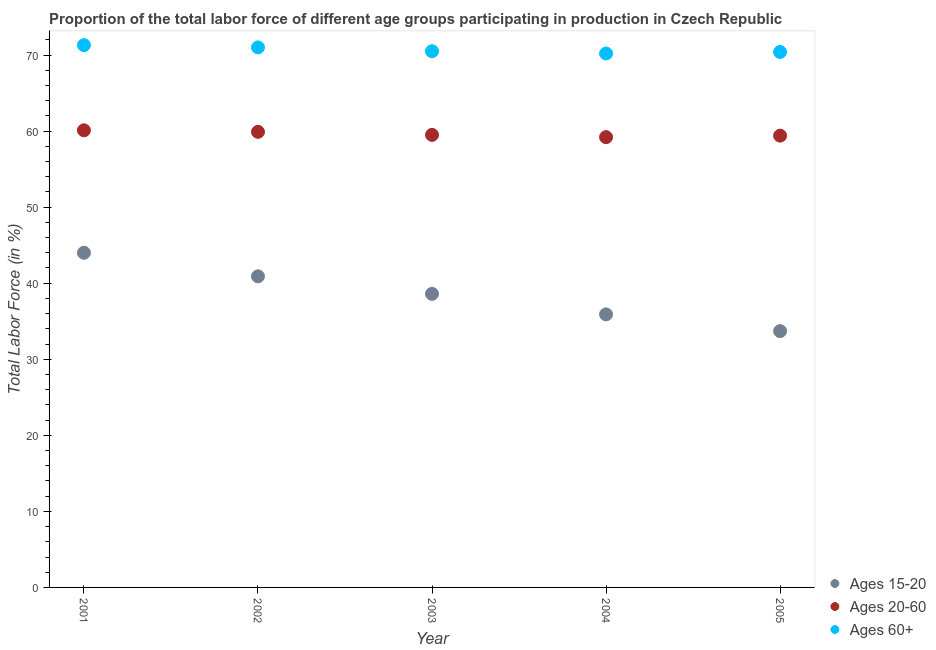How many different coloured dotlines are there?
Your answer should be compact. 3. Is the number of dotlines equal to the number of legend labels?
Offer a very short reply. Yes. What is the percentage of labor force above age 60 in 2003?
Offer a very short reply. 70.5. Across all years, what is the maximum percentage of labor force within the age group 20-60?
Your answer should be very brief. 60.1. Across all years, what is the minimum percentage of labor force above age 60?
Make the answer very short. 70.2. In which year was the percentage of labor force within the age group 20-60 maximum?
Give a very brief answer. 2001. What is the total percentage of labor force within the age group 20-60 in the graph?
Provide a succinct answer. 298.1. What is the difference between the percentage of labor force above age 60 in 2001 and that in 2003?
Give a very brief answer. 0.8. What is the difference between the percentage of labor force above age 60 in 2005 and the percentage of labor force within the age group 15-20 in 2004?
Your response must be concise. 34.5. What is the average percentage of labor force above age 60 per year?
Keep it short and to the point. 70.68. In the year 2001, what is the difference between the percentage of labor force above age 60 and percentage of labor force within the age group 20-60?
Provide a short and direct response. 11.2. In how many years, is the percentage of labor force above age 60 greater than 46 %?
Ensure brevity in your answer.  5. What is the ratio of the percentage of labor force within the age group 20-60 in 2002 to that in 2003?
Provide a short and direct response. 1.01. What is the difference between the highest and the second highest percentage of labor force above age 60?
Ensure brevity in your answer.  0.3. What is the difference between the highest and the lowest percentage of labor force above age 60?
Make the answer very short. 1.1. Is it the case that in every year, the sum of the percentage of labor force within the age group 15-20 and percentage of labor force within the age group 20-60 is greater than the percentage of labor force above age 60?
Offer a very short reply. Yes. How many dotlines are there?
Give a very brief answer. 3. How many years are there in the graph?
Make the answer very short. 5. Are the values on the major ticks of Y-axis written in scientific E-notation?
Provide a short and direct response. No. Does the graph contain grids?
Offer a terse response. No. Where does the legend appear in the graph?
Ensure brevity in your answer.  Bottom right. How many legend labels are there?
Offer a very short reply. 3. How are the legend labels stacked?
Your answer should be very brief. Vertical. What is the title of the graph?
Offer a very short reply. Proportion of the total labor force of different age groups participating in production in Czech Republic. What is the label or title of the X-axis?
Offer a very short reply. Year. What is the label or title of the Y-axis?
Your answer should be compact. Total Labor Force (in %). What is the Total Labor Force (in %) in Ages 15-20 in 2001?
Your answer should be compact. 44. What is the Total Labor Force (in %) in Ages 20-60 in 2001?
Your answer should be very brief. 60.1. What is the Total Labor Force (in %) of Ages 60+ in 2001?
Provide a short and direct response. 71.3. What is the Total Labor Force (in %) of Ages 15-20 in 2002?
Your response must be concise. 40.9. What is the Total Labor Force (in %) of Ages 20-60 in 2002?
Give a very brief answer. 59.9. What is the Total Labor Force (in %) in Ages 15-20 in 2003?
Ensure brevity in your answer.  38.6. What is the Total Labor Force (in %) in Ages 20-60 in 2003?
Make the answer very short. 59.5. What is the Total Labor Force (in %) in Ages 60+ in 2003?
Your response must be concise. 70.5. What is the Total Labor Force (in %) of Ages 15-20 in 2004?
Give a very brief answer. 35.9. What is the Total Labor Force (in %) in Ages 20-60 in 2004?
Offer a terse response. 59.2. What is the Total Labor Force (in %) of Ages 60+ in 2004?
Your answer should be compact. 70.2. What is the Total Labor Force (in %) of Ages 15-20 in 2005?
Give a very brief answer. 33.7. What is the Total Labor Force (in %) of Ages 20-60 in 2005?
Give a very brief answer. 59.4. What is the Total Labor Force (in %) of Ages 60+ in 2005?
Offer a very short reply. 70.4. Across all years, what is the maximum Total Labor Force (in %) in Ages 20-60?
Ensure brevity in your answer.  60.1. Across all years, what is the maximum Total Labor Force (in %) of Ages 60+?
Keep it short and to the point. 71.3. Across all years, what is the minimum Total Labor Force (in %) of Ages 15-20?
Provide a succinct answer. 33.7. Across all years, what is the minimum Total Labor Force (in %) of Ages 20-60?
Keep it short and to the point. 59.2. Across all years, what is the minimum Total Labor Force (in %) of Ages 60+?
Your answer should be very brief. 70.2. What is the total Total Labor Force (in %) of Ages 15-20 in the graph?
Offer a terse response. 193.1. What is the total Total Labor Force (in %) of Ages 20-60 in the graph?
Your answer should be compact. 298.1. What is the total Total Labor Force (in %) of Ages 60+ in the graph?
Give a very brief answer. 353.4. What is the difference between the Total Labor Force (in %) in Ages 20-60 in 2001 and that in 2002?
Ensure brevity in your answer.  0.2. What is the difference between the Total Labor Force (in %) in Ages 60+ in 2001 and that in 2002?
Provide a short and direct response. 0.3. What is the difference between the Total Labor Force (in %) in Ages 20-60 in 2001 and that in 2004?
Offer a terse response. 0.9. What is the difference between the Total Labor Force (in %) in Ages 15-20 in 2001 and that in 2005?
Give a very brief answer. 10.3. What is the difference between the Total Labor Force (in %) of Ages 60+ in 2001 and that in 2005?
Ensure brevity in your answer.  0.9. What is the difference between the Total Labor Force (in %) of Ages 20-60 in 2002 and that in 2004?
Provide a short and direct response. 0.7. What is the difference between the Total Labor Force (in %) in Ages 15-20 in 2002 and that in 2005?
Provide a succinct answer. 7.2. What is the difference between the Total Labor Force (in %) of Ages 60+ in 2002 and that in 2005?
Make the answer very short. 0.6. What is the difference between the Total Labor Force (in %) in Ages 60+ in 2003 and that in 2004?
Your response must be concise. 0.3. What is the difference between the Total Labor Force (in %) of Ages 20-60 in 2003 and that in 2005?
Make the answer very short. 0.1. What is the difference between the Total Labor Force (in %) of Ages 60+ in 2003 and that in 2005?
Ensure brevity in your answer.  0.1. What is the difference between the Total Labor Force (in %) in Ages 15-20 in 2004 and that in 2005?
Your response must be concise. 2.2. What is the difference between the Total Labor Force (in %) of Ages 20-60 in 2004 and that in 2005?
Ensure brevity in your answer.  -0.2. What is the difference between the Total Labor Force (in %) in Ages 60+ in 2004 and that in 2005?
Make the answer very short. -0.2. What is the difference between the Total Labor Force (in %) of Ages 15-20 in 2001 and the Total Labor Force (in %) of Ages 20-60 in 2002?
Offer a terse response. -15.9. What is the difference between the Total Labor Force (in %) in Ages 15-20 in 2001 and the Total Labor Force (in %) in Ages 20-60 in 2003?
Keep it short and to the point. -15.5. What is the difference between the Total Labor Force (in %) of Ages 15-20 in 2001 and the Total Labor Force (in %) of Ages 60+ in 2003?
Make the answer very short. -26.5. What is the difference between the Total Labor Force (in %) in Ages 20-60 in 2001 and the Total Labor Force (in %) in Ages 60+ in 2003?
Offer a terse response. -10.4. What is the difference between the Total Labor Force (in %) of Ages 15-20 in 2001 and the Total Labor Force (in %) of Ages 20-60 in 2004?
Keep it short and to the point. -15.2. What is the difference between the Total Labor Force (in %) of Ages 15-20 in 2001 and the Total Labor Force (in %) of Ages 60+ in 2004?
Provide a succinct answer. -26.2. What is the difference between the Total Labor Force (in %) in Ages 15-20 in 2001 and the Total Labor Force (in %) in Ages 20-60 in 2005?
Give a very brief answer. -15.4. What is the difference between the Total Labor Force (in %) of Ages 15-20 in 2001 and the Total Labor Force (in %) of Ages 60+ in 2005?
Your answer should be very brief. -26.4. What is the difference between the Total Labor Force (in %) of Ages 15-20 in 2002 and the Total Labor Force (in %) of Ages 20-60 in 2003?
Offer a terse response. -18.6. What is the difference between the Total Labor Force (in %) of Ages 15-20 in 2002 and the Total Labor Force (in %) of Ages 60+ in 2003?
Your answer should be compact. -29.6. What is the difference between the Total Labor Force (in %) in Ages 20-60 in 2002 and the Total Labor Force (in %) in Ages 60+ in 2003?
Ensure brevity in your answer.  -10.6. What is the difference between the Total Labor Force (in %) in Ages 15-20 in 2002 and the Total Labor Force (in %) in Ages 20-60 in 2004?
Give a very brief answer. -18.3. What is the difference between the Total Labor Force (in %) in Ages 15-20 in 2002 and the Total Labor Force (in %) in Ages 60+ in 2004?
Your answer should be compact. -29.3. What is the difference between the Total Labor Force (in %) in Ages 15-20 in 2002 and the Total Labor Force (in %) in Ages 20-60 in 2005?
Ensure brevity in your answer.  -18.5. What is the difference between the Total Labor Force (in %) in Ages 15-20 in 2002 and the Total Labor Force (in %) in Ages 60+ in 2005?
Keep it short and to the point. -29.5. What is the difference between the Total Labor Force (in %) of Ages 20-60 in 2002 and the Total Labor Force (in %) of Ages 60+ in 2005?
Your answer should be very brief. -10.5. What is the difference between the Total Labor Force (in %) of Ages 15-20 in 2003 and the Total Labor Force (in %) of Ages 20-60 in 2004?
Provide a succinct answer. -20.6. What is the difference between the Total Labor Force (in %) of Ages 15-20 in 2003 and the Total Labor Force (in %) of Ages 60+ in 2004?
Your answer should be compact. -31.6. What is the difference between the Total Labor Force (in %) in Ages 20-60 in 2003 and the Total Labor Force (in %) in Ages 60+ in 2004?
Your answer should be compact. -10.7. What is the difference between the Total Labor Force (in %) of Ages 15-20 in 2003 and the Total Labor Force (in %) of Ages 20-60 in 2005?
Offer a very short reply. -20.8. What is the difference between the Total Labor Force (in %) in Ages 15-20 in 2003 and the Total Labor Force (in %) in Ages 60+ in 2005?
Your response must be concise. -31.8. What is the difference between the Total Labor Force (in %) in Ages 15-20 in 2004 and the Total Labor Force (in %) in Ages 20-60 in 2005?
Offer a very short reply. -23.5. What is the difference between the Total Labor Force (in %) of Ages 15-20 in 2004 and the Total Labor Force (in %) of Ages 60+ in 2005?
Offer a very short reply. -34.5. What is the average Total Labor Force (in %) of Ages 15-20 per year?
Offer a very short reply. 38.62. What is the average Total Labor Force (in %) of Ages 20-60 per year?
Provide a short and direct response. 59.62. What is the average Total Labor Force (in %) of Ages 60+ per year?
Your answer should be compact. 70.68. In the year 2001, what is the difference between the Total Labor Force (in %) in Ages 15-20 and Total Labor Force (in %) in Ages 20-60?
Your response must be concise. -16.1. In the year 2001, what is the difference between the Total Labor Force (in %) in Ages 15-20 and Total Labor Force (in %) in Ages 60+?
Make the answer very short. -27.3. In the year 2002, what is the difference between the Total Labor Force (in %) of Ages 15-20 and Total Labor Force (in %) of Ages 60+?
Make the answer very short. -30.1. In the year 2002, what is the difference between the Total Labor Force (in %) of Ages 20-60 and Total Labor Force (in %) of Ages 60+?
Make the answer very short. -11.1. In the year 2003, what is the difference between the Total Labor Force (in %) in Ages 15-20 and Total Labor Force (in %) in Ages 20-60?
Provide a succinct answer. -20.9. In the year 2003, what is the difference between the Total Labor Force (in %) of Ages 15-20 and Total Labor Force (in %) of Ages 60+?
Ensure brevity in your answer.  -31.9. In the year 2003, what is the difference between the Total Labor Force (in %) of Ages 20-60 and Total Labor Force (in %) of Ages 60+?
Provide a short and direct response. -11. In the year 2004, what is the difference between the Total Labor Force (in %) in Ages 15-20 and Total Labor Force (in %) in Ages 20-60?
Offer a very short reply. -23.3. In the year 2004, what is the difference between the Total Labor Force (in %) in Ages 15-20 and Total Labor Force (in %) in Ages 60+?
Provide a succinct answer. -34.3. In the year 2004, what is the difference between the Total Labor Force (in %) in Ages 20-60 and Total Labor Force (in %) in Ages 60+?
Your response must be concise. -11. In the year 2005, what is the difference between the Total Labor Force (in %) of Ages 15-20 and Total Labor Force (in %) of Ages 20-60?
Keep it short and to the point. -25.7. In the year 2005, what is the difference between the Total Labor Force (in %) in Ages 15-20 and Total Labor Force (in %) in Ages 60+?
Keep it short and to the point. -36.7. What is the ratio of the Total Labor Force (in %) in Ages 15-20 in 2001 to that in 2002?
Provide a succinct answer. 1.08. What is the ratio of the Total Labor Force (in %) of Ages 20-60 in 2001 to that in 2002?
Your answer should be compact. 1. What is the ratio of the Total Labor Force (in %) in Ages 15-20 in 2001 to that in 2003?
Make the answer very short. 1.14. What is the ratio of the Total Labor Force (in %) in Ages 60+ in 2001 to that in 2003?
Provide a succinct answer. 1.01. What is the ratio of the Total Labor Force (in %) of Ages 15-20 in 2001 to that in 2004?
Your answer should be very brief. 1.23. What is the ratio of the Total Labor Force (in %) of Ages 20-60 in 2001 to that in 2004?
Ensure brevity in your answer.  1.02. What is the ratio of the Total Labor Force (in %) of Ages 60+ in 2001 to that in 2004?
Your answer should be very brief. 1.02. What is the ratio of the Total Labor Force (in %) in Ages 15-20 in 2001 to that in 2005?
Make the answer very short. 1.31. What is the ratio of the Total Labor Force (in %) in Ages 20-60 in 2001 to that in 2005?
Offer a very short reply. 1.01. What is the ratio of the Total Labor Force (in %) of Ages 60+ in 2001 to that in 2005?
Your answer should be compact. 1.01. What is the ratio of the Total Labor Force (in %) in Ages 15-20 in 2002 to that in 2003?
Your response must be concise. 1.06. What is the ratio of the Total Labor Force (in %) of Ages 20-60 in 2002 to that in 2003?
Your answer should be very brief. 1.01. What is the ratio of the Total Labor Force (in %) in Ages 60+ in 2002 to that in 2003?
Provide a short and direct response. 1.01. What is the ratio of the Total Labor Force (in %) of Ages 15-20 in 2002 to that in 2004?
Make the answer very short. 1.14. What is the ratio of the Total Labor Force (in %) of Ages 20-60 in 2002 to that in 2004?
Give a very brief answer. 1.01. What is the ratio of the Total Labor Force (in %) in Ages 60+ in 2002 to that in 2004?
Ensure brevity in your answer.  1.01. What is the ratio of the Total Labor Force (in %) of Ages 15-20 in 2002 to that in 2005?
Provide a short and direct response. 1.21. What is the ratio of the Total Labor Force (in %) in Ages 20-60 in 2002 to that in 2005?
Offer a terse response. 1.01. What is the ratio of the Total Labor Force (in %) of Ages 60+ in 2002 to that in 2005?
Your response must be concise. 1.01. What is the ratio of the Total Labor Force (in %) in Ages 15-20 in 2003 to that in 2004?
Your answer should be compact. 1.08. What is the ratio of the Total Labor Force (in %) of Ages 15-20 in 2003 to that in 2005?
Ensure brevity in your answer.  1.15. What is the ratio of the Total Labor Force (in %) of Ages 15-20 in 2004 to that in 2005?
Provide a short and direct response. 1.07. What is the ratio of the Total Labor Force (in %) of Ages 20-60 in 2004 to that in 2005?
Keep it short and to the point. 1. What is the difference between the highest and the second highest Total Labor Force (in %) in Ages 20-60?
Ensure brevity in your answer.  0.2. What is the difference between the highest and the lowest Total Labor Force (in %) of Ages 15-20?
Ensure brevity in your answer.  10.3. What is the difference between the highest and the lowest Total Labor Force (in %) in Ages 60+?
Ensure brevity in your answer.  1.1. 